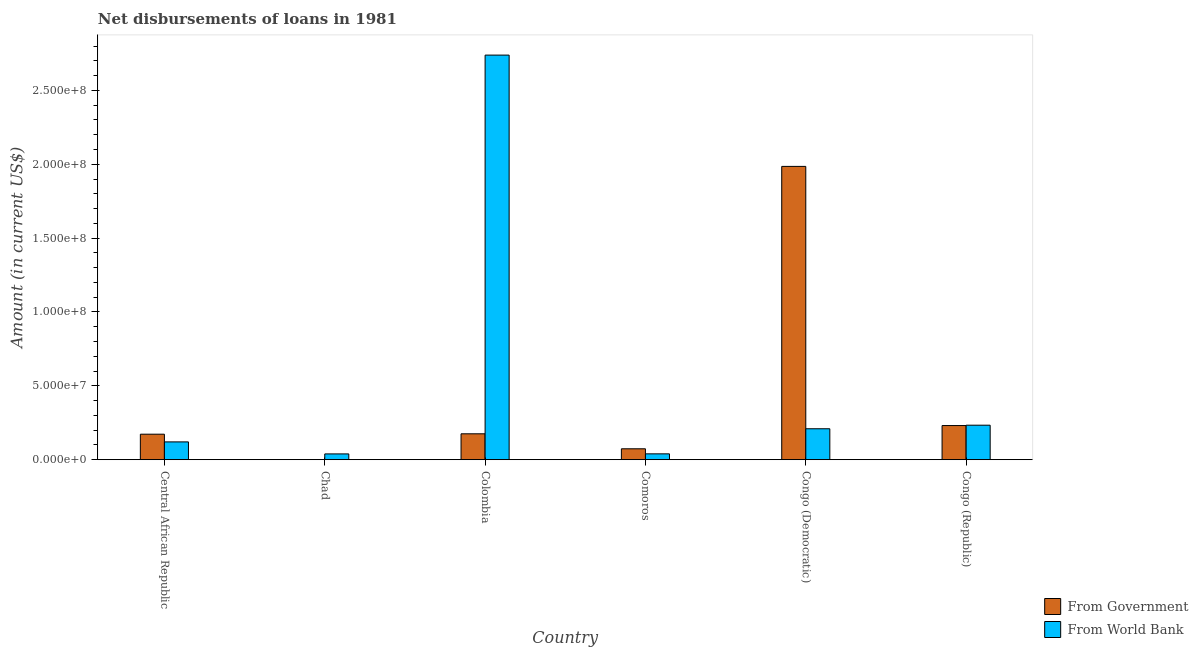What is the label of the 2nd group of bars from the left?
Ensure brevity in your answer.  Chad. What is the net disbursements of loan from government in Congo (Republic)?
Provide a succinct answer. 2.31e+07. Across all countries, what is the maximum net disbursements of loan from world bank?
Ensure brevity in your answer.  2.74e+08. Across all countries, what is the minimum net disbursements of loan from government?
Offer a terse response. 0. In which country was the net disbursements of loan from government maximum?
Ensure brevity in your answer.  Congo (Democratic). What is the total net disbursements of loan from government in the graph?
Keep it short and to the point. 2.64e+08. What is the difference between the net disbursements of loan from government in Colombia and that in Comoros?
Ensure brevity in your answer.  1.01e+07. What is the difference between the net disbursements of loan from world bank in Comoros and the net disbursements of loan from government in Central African Republic?
Your response must be concise. -1.33e+07. What is the average net disbursements of loan from government per country?
Ensure brevity in your answer.  4.40e+07. What is the difference between the net disbursements of loan from government and net disbursements of loan from world bank in Comoros?
Your answer should be very brief. 3.43e+06. What is the ratio of the net disbursements of loan from world bank in Chad to that in Colombia?
Your response must be concise. 0.01. What is the difference between the highest and the second highest net disbursements of loan from government?
Your response must be concise. 1.75e+08. What is the difference between the highest and the lowest net disbursements of loan from world bank?
Make the answer very short. 2.70e+08. Is the sum of the net disbursements of loan from world bank in Chad and Colombia greater than the maximum net disbursements of loan from government across all countries?
Offer a very short reply. Yes. Are all the bars in the graph horizontal?
Give a very brief answer. No. How many countries are there in the graph?
Provide a short and direct response. 6. Does the graph contain any zero values?
Your answer should be compact. Yes. How are the legend labels stacked?
Provide a succinct answer. Vertical. What is the title of the graph?
Your answer should be very brief. Net disbursements of loans in 1981. Does "Non-resident workers" appear as one of the legend labels in the graph?
Provide a short and direct response. No. What is the label or title of the X-axis?
Provide a succinct answer. Country. What is the label or title of the Y-axis?
Provide a short and direct response. Amount (in current US$). What is the Amount (in current US$) of From Government in Central African Republic?
Provide a succinct answer. 1.73e+07. What is the Amount (in current US$) in From World Bank in Central African Republic?
Your answer should be very brief. 1.20e+07. What is the Amount (in current US$) in From World Bank in Chad?
Provide a short and direct response. 3.92e+06. What is the Amount (in current US$) in From Government in Colombia?
Ensure brevity in your answer.  1.75e+07. What is the Amount (in current US$) in From World Bank in Colombia?
Your response must be concise. 2.74e+08. What is the Amount (in current US$) in From Government in Comoros?
Give a very brief answer. 7.38e+06. What is the Amount (in current US$) of From World Bank in Comoros?
Keep it short and to the point. 3.95e+06. What is the Amount (in current US$) of From Government in Congo (Democratic)?
Offer a terse response. 1.99e+08. What is the Amount (in current US$) of From World Bank in Congo (Democratic)?
Ensure brevity in your answer.  2.09e+07. What is the Amount (in current US$) in From Government in Congo (Republic)?
Your answer should be compact. 2.31e+07. What is the Amount (in current US$) of From World Bank in Congo (Republic)?
Provide a succinct answer. 2.34e+07. Across all countries, what is the maximum Amount (in current US$) in From Government?
Make the answer very short. 1.99e+08. Across all countries, what is the maximum Amount (in current US$) of From World Bank?
Give a very brief answer. 2.74e+08. Across all countries, what is the minimum Amount (in current US$) of From World Bank?
Offer a very short reply. 3.92e+06. What is the total Amount (in current US$) in From Government in the graph?
Provide a succinct answer. 2.64e+08. What is the total Amount (in current US$) in From World Bank in the graph?
Your answer should be compact. 3.38e+08. What is the difference between the Amount (in current US$) in From World Bank in Central African Republic and that in Chad?
Provide a short and direct response. 8.14e+06. What is the difference between the Amount (in current US$) of From Government in Central African Republic and that in Colombia?
Provide a succinct answer. -2.67e+05. What is the difference between the Amount (in current US$) in From World Bank in Central African Republic and that in Colombia?
Provide a short and direct response. -2.62e+08. What is the difference between the Amount (in current US$) in From Government in Central African Republic and that in Comoros?
Offer a terse response. 9.88e+06. What is the difference between the Amount (in current US$) of From World Bank in Central African Republic and that in Comoros?
Make the answer very short. 8.10e+06. What is the difference between the Amount (in current US$) of From Government in Central African Republic and that in Congo (Democratic)?
Offer a terse response. -1.81e+08. What is the difference between the Amount (in current US$) in From World Bank in Central African Republic and that in Congo (Democratic)?
Offer a very short reply. -8.89e+06. What is the difference between the Amount (in current US$) of From Government in Central African Republic and that in Congo (Republic)?
Provide a succinct answer. -5.85e+06. What is the difference between the Amount (in current US$) in From World Bank in Central African Republic and that in Congo (Republic)?
Give a very brief answer. -1.13e+07. What is the difference between the Amount (in current US$) of From World Bank in Chad and that in Colombia?
Offer a very short reply. -2.70e+08. What is the difference between the Amount (in current US$) in From World Bank in Chad and that in Comoros?
Give a very brief answer. -3.80e+04. What is the difference between the Amount (in current US$) of From World Bank in Chad and that in Congo (Democratic)?
Make the answer very short. -1.70e+07. What is the difference between the Amount (in current US$) in From World Bank in Chad and that in Congo (Republic)?
Your answer should be very brief. -1.94e+07. What is the difference between the Amount (in current US$) of From Government in Colombia and that in Comoros?
Make the answer very short. 1.01e+07. What is the difference between the Amount (in current US$) of From World Bank in Colombia and that in Comoros?
Offer a terse response. 2.70e+08. What is the difference between the Amount (in current US$) in From Government in Colombia and that in Congo (Democratic)?
Offer a very short reply. -1.81e+08. What is the difference between the Amount (in current US$) in From World Bank in Colombia and that in Congo (Democratic)?
Provide a short and direct response. 2.53e+08. What is the difference between the Amount (in current US$) in From Government in Colombia and that in Congo (Republic)?
Offer a terse response. -5.58e+06. What is the difference between the Amount (in current US$) in From World Bank in Colombia and that in Congo (Republic)?
Provide a succinct answer. 2.51e+08. What is the difference between the Amount (in current US$) of From Government in Comoros and that in Congo (Democratic)?
Offer a very short reply. -1.91e+08. What is the difference between the Amount (in current US$) in From World Bank in Comoros and that in Congo (Democratic)?
Make the answer very short. -1.70e+07. What is the difference between the Amount (in current US$) in From Government in Comoros and that in Congo (Republic)?
Offer a terse response. -1.57e+07. What is the difference between the Amount (in current US$) of From World Bank in Comoros and that in Congo (Republic)?
Keep it short and to the point. -1.94e+07. What is the difference between the Amount (in current US$) of From Government in Congo (Democratic) and that in Congo (Republic)?
Your answer should be compact. 1.75e+08. What is the difference between the Amount (in current US$) in From World Bank in Congo (Democratic) and that in Congo (Republic)?
Provide a succinct answer. -2.41e+06. What is the difference between the Amount (in current US$) of From Government in Central African Republic and the Amount (in current US$) of From World Bank in Chad?
Make the answer very short. 1.33e+07. What is the difference between the Amount (in current US$) in From Government in Central African Republic and the Amount (in current US$) in From World Bank in Colombia?
Provide a short and direct response. -2.57e+08. What is the difference between the Amount (in current US$) of From Government in Central African Republic and the Amount (in current US$) of From World Bank in Comoros?
Make the answer very short. 1.33e+07. What is the difference between the Amount (in current US$) in From Government in Central African Republic and the Amount (in current US$) in From World Bank in Congo (Democratic)?
Give a very brief answer. -3.68e+06. What is the difference between the Amount (in current US$) of From Government in Central African Republic and the Amount (in current US$) of From World Bank in Congo (Republic)?
Give a very brief answer. -6.09e+06. What is the difference between the Amount (in current US$) of From Government in Colombia and the Amount (in current US$) of From World Bank in Comoros?
Offer a very short reply. 1.36e+07. What is the difference between the Amount (in current US$) of From Government in Colombia and the Amount (in current US$) of From World Bank in Congo (Democratic)?
Your answer should be very brief. -3.41e+06. What is the difference between the Amount (in current US$) in From Government in Colombia and the Amount (in current US$) in From World Bank in Congo (Republic)?
Offer a terse response. -5.82e+06. What is the difference between the Amount (in current US$) of From Government in Comoros and the Amount (in current US$) of From World Bank in Congo (Democratic)?
Your response must be concise. -1.36e+07. What is the difference between the Amount (in current US$) in From Government in Comoros and the Amount (in current US$) in From World Bank in Congo (Republic)?
Provide a short and direct response. -1.60e+07. What is the difference between the Amount (in current US$) in From Government in Congo (Democratic) and the Amount (in current US$) in From World Bank in Congo (Republic)?
Provide a succinct answer. 1.75e+08. What is the average Amount (in current US$) in From Government per country?
Give a very brief answer. 4.40e+07. What is the average Amount (in current US$) of From World Bank per country?
Make the answer very short. 5.63e+07. What is the difference between the Amount (in current US$) of From Government and Amount (in current US$) of From World Bank in Central African Republic?
Keep it short and to the point. 5.21e+06. What is the difference between the Amount (in current US$) in From Government and Amount (in current US$) in From World Bank in Colombia?
Offer a very short reply. -2.56e+08. What is the difference between the Amount (in current US$) in From Government and Amount (in current US$) in From World Bank in Comoros?
Keep it short and to the point. 3.43e+06. What is the difference between the Amount (in current US$) in From Government and Amount (in current US$) in From World Bank in Congo (Democratic)?
Offer a terse response. 1.78e+08. What is the difference between the Amount (in current US$) of From Government and Amount (in current US$) of From World Bank in Congo (Republic)?
Your answer should be compact. -2.42e+05. What is the ratio of the Amount (in current US$) of From World Bank in Central African Republic to that in Chad?
Provide a succinct answer. 3.08. What is the ratio of the Amount (in current US$) of From Government in Central African Republic to that in Colombia?
Your answer should be very brief. 0.98. What is the ratio of the Amount (in current US$) of From World Bank in Central African Republic to that in Colombia?
Provide a succinct answer. 0.04. What is the ratio of the Amount (in current US$) in From Government in Central African Republic to that in Comoros?
Offer a very short reply. 2.34. What is the ratio of the Amount (in current US$) in From World Bank in Central African Republic to that in Comoros?
Offer a very short reply. 3.05. What is the ratio of the Amount (in current US$) of From Government in Central African Republic to that in Congo (Democratic)?
Your answer should be very brief. 0.09. What is the ratio of the Amount (in current US$) in From World Bank in Central African Republic to that in Congo (Democratic)?
Your answer should be compact. 0.58. What is the ratio of the Amount (in current US$) of From Government in Central African Republic to that in Congo (Republic)?
Give a very brief answer. 0.75. What is the ratio of the Amount (in current US$) in From World Bank in Central African Republic to that in Congo (Republic)?
Offer a very short reply. 0.52. What is the ratio of the Amount (in current US$) in From World Bank in Chad to that in Colombia?
Give a very brief answer. 0.01. What is the ratio of the Amount (in current US$) of From World Bank in Chad to that in Congo (Democratic)?
Your response must be concise. 0.19. What is the ratio of the Amount (in current US$) in From World Bank in Chad to that in Congo (Republic)?
Your response must be concise. 0.17. What is the ratio of the Amount (in current US$) in From Government in Colombia to that in Comoros?
Provide a short and direct response. 2.37. What is the ratio of the Amount (in current US$) of From World Bank in Colombia to that in Comoros?
Provide a short and direct response. 69.28. What is the ratio of the Amount (in current US$) of From Government in Colombia to that in Congo (Democratic)?
Your answer should be compact. 0.09. What is the ratio of the Amount (in current US$) in From World Bank in Colombia to that in Congo (Democratic)?
Ensure brevity in your answer.  13.08. What is the ratio of the Amount (in current US$) in From Government in Colombia to that in Congo (Republic)?
Provide a succinct answer. 0.76. What is the ratio of the Amount (in current US$) of From World Bank in Colombia to that in Congo (Republic)?
Make the answer very short. 11.73. What is the ratio of the Amount (in current US$) of From Government in Comoros to that in Congo (Democratic)?
Your answer should be compact. 0.04. What is the ratio of the Amount (in current US$) in From World Bank in Comoros to that in Congo (Democratic)?
Offer a very short reply. 0.19. What is the ratio of the Amount (in current US$) of From Government in Comoros to that in Congo (Republic)?
Offer a terse response. 0.32. What is the ratio of the Amount (in current US$) in From World Bank in Comoros to that in Congo (Republic)?
Your answer should be very brief. 0.17. What is the ratio of the Amount (in current US$) of From Government in Congo (Democratic) to that in Congo (Republic)?
Your response must be concise. 8.59. What is the ratio of the Amount (in current US$) of From World Bank in Congo (Democratic) to that in Congo (Republic)?
Offer a terse response. 0.9. What is the difference between the highest and the second highest Amount (in current US$) of From Government?
Your response must be concise. 1.75e+08. What is the difference between the highest and the second highest Amount (in current US$) of From World Bank?
Keep it short and to the point. 2.51e+08. What is the difference between the highest and the lowest Amount (in current US$) of From Government?
Provide a succinct answer. 1.99e+08. What is the difference between the highest and the lowest Amount (in current US$) of From World Bank?
Give a very brief answer. 2.70e+08. 